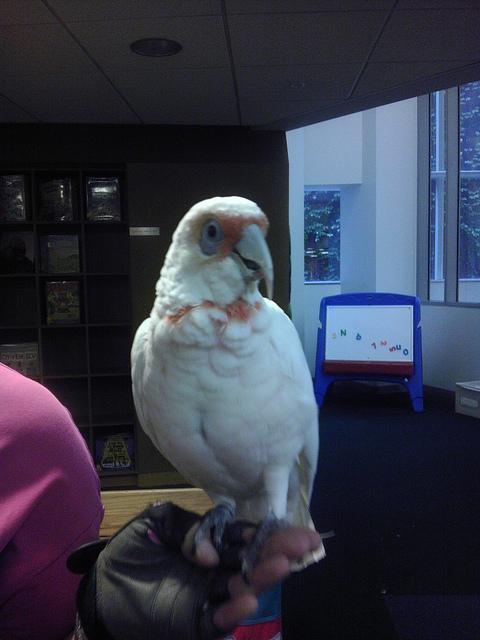Evaluate: Does the caption "The bird is in the tv." match the image?
Answer yes or no. No. 